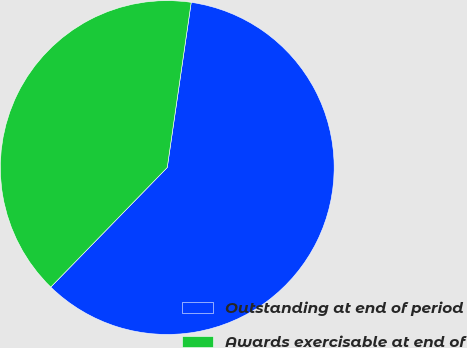Convert chart. <chart><loc_0><loc_0><loc_500><loc_500><pie_chart><fcel>Outstanding at end of period<fcel>Awards exercisable at end of<nl><fcel>60.0%<fcel>40.0%<nl></chart> 